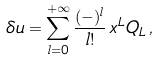Convert formula to latex. <formula><loc_0><loc_0><loc_500><loc_500>\delta u = \sum _ { l = 0 } ^ { + \infty } \frac { ( - ) ^ { l } } { l ! } \, x ^ { L } Q _ { L } \, ,</formula> 